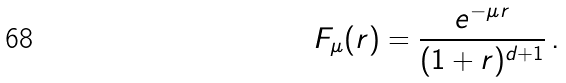Convert formula to latex. <formula><loc_0><loc_0><loc_500><loc_500>F _ { \mu } ( r ) = \frac { e ^ { - \mu r } } { ( 1 + r ) ^ { d + 1 } } \, .</formula> 